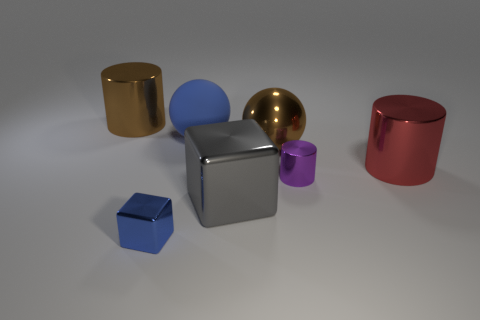Add 2 large blue blocks. How many objects exist? 9 Subtract all red cubes. Subtract all yellow cylinders. How many cubes are left? 2 Subtract all cylinders. How many objects are left? 4 Subtract 1 blue spheres. How many objects are left? 6 Subtract all big matte objects. Subtract all small cubes. How many objects are left? 5 Add 5 blue rubber things. How many blue rubber things are left? 6 Add 2 cylinders. How many cylinders exist? 5 